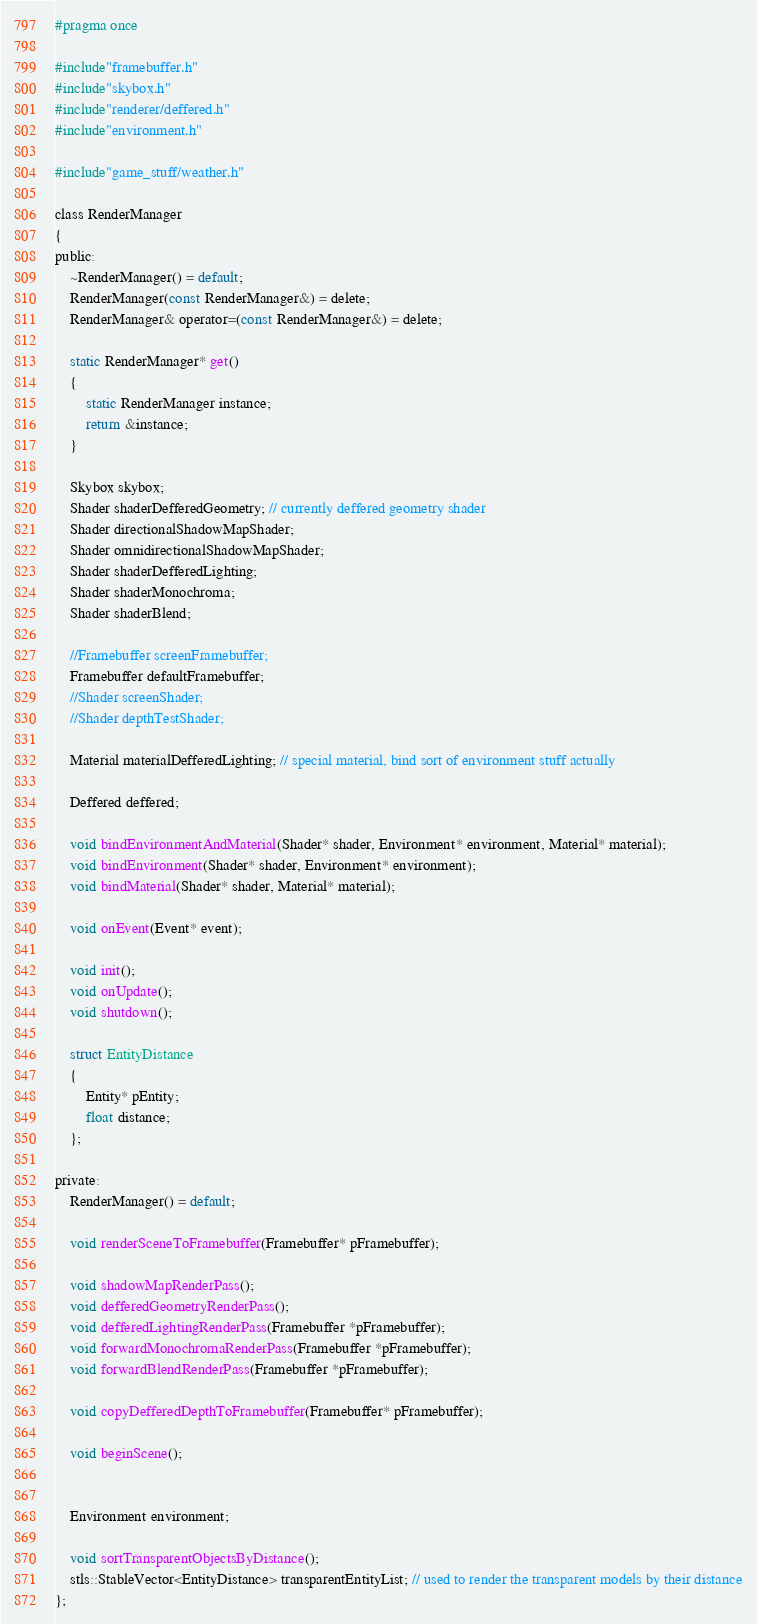<code> <loc_0><loc_0><loc_500><loc_500><_C_>#pragma once

#include"framebuffer.h"
#include"skybox.h"
#include"renderer/deffered.h"
#include"environment.h"

#include"game_stuff/weather.h"

class RenderManager
{
public:
    ~RenderManager() = default;
    RenderManager(const RenderManager&) = delete;
    RenderManager& operator=(const RenderManager&) = delete;
    
    static RenderManager* get()
    {
        static RenderManager instance;
        return &instance;
    }

    Skybox skybox;
    Shader shaderDefferedGeometry; // currently deffered geometry shader
    Shader directionalShadowMapShader;
    Shader omnidirectionalShadowMapShader;
    Shader shaderDefferedLighting;
    Shader shaderMonochroma;
    Shader shaderBlend;

    //Framebuffer screenFramebuffer;
    Framebuffer defaultFramebuffer;
    //Shader screenShader;
    //Shader depthTestShader;
    
    Material materialDefferedLighting; // special material, bind sort of environment stuff actually

    Deffered deffered;

    void bindEnvironmentAndMaterial(Shader* shader, Environment* environment, Material* material);
    void bindEnvironment(Shader* shader, Environment* environment);
    void bindMaterial(Shader* shader, Material* material);

    void onEvent(Event* event);

    void init();
    void onUpdate();
    void shutdown();

    struct EntityDistance
    {
        Entity* pEntity;
        float distance;
    };

private:
    RenderManager() = default;

    void renderSceneToFramebuffer(Framebuffer* pFramebuffer);

    void shadowMapRenderPass();
    void defferedGeometryRenderPass();
    void defferedLightingRenderPass(Framebuffer *pFramebuffer);
    void forwardMonochromaRenderPass(Framebuffer *pFramebuffer);
    void forwardBlendRenderPass(Framebuffer *pFramebuffer);

    void copyDefferedDepthToFramebuffer(Framebuffer* pFramebuffer);

    void beginScene();


    Environment environment;

    void sortTransparentObjectsByDistance();
    stls::StableVector<EntityDistance> transparentEntityList; // used to render the transparent models by their distance
};
</code> 